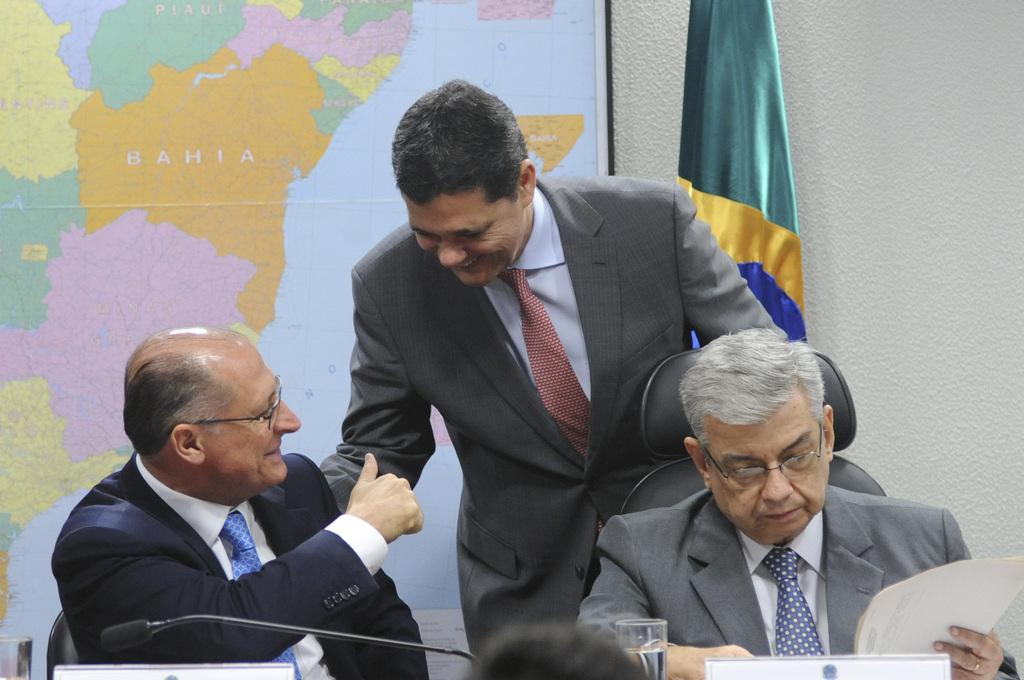How many people are present in the image? There are 2 people sitting in the image. What are the people wearing? The people are wearing suits. What object can be seen in the image that is typically used for amplifying sound? There is a microphone in the image. What is the purpose of the glass of water in the image? The glass of water is likely for the people to drink during their discussion or presentation. What type of object can be seen in the image that represents a geographical area? There is a map in the image. What symbolic object is present in the image? There is a flag in the image. What type of wilderness can be seen in the background of the image? There is no wilderness visible in the image; it is focused on the people and objects mentioned in the facts. 